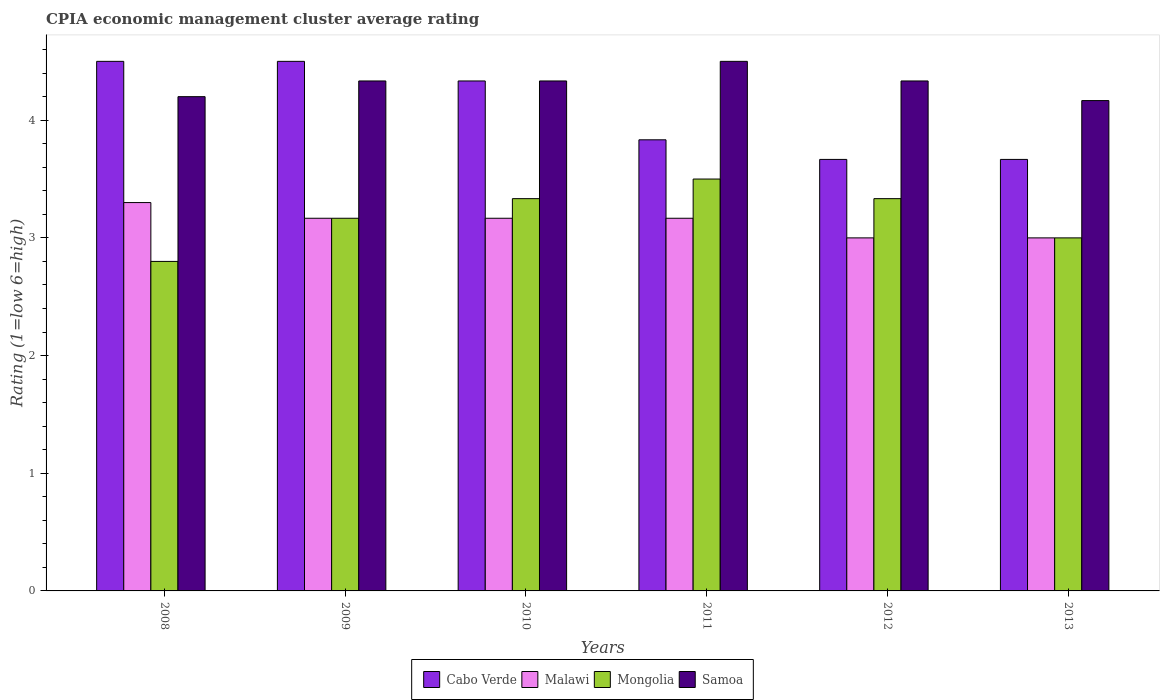How many different coloured bars are there?
Offer a terse response. 4. How many groups of bars are there?
Give a very brief answer. 6. What is the CPIA rating in Samoa in 2012?
Provide a short and direct response. 4.33. In which year was the CPIA rating in Malawi minimum?
Give a very brief answer. 2012. What is the total CPIA rating in Mongolia in the graph?
Your answer should be compact. 19.13. What is the difference between the CPIA rating in Malawi in 2011 and that in 2012?
Give a very brief answer. 0.17. What is the difference between the CPIA rating in Mongolia in 2010 and the CPIA rating in Malawi in 2009?
Give a very brief answer. 0.17. What is the average CPIA rating in Malawi per year?
Your answer should be compact. 3.13. In the year 2009, what is the difference between the CPIA rating in Mongolia and CPIA rating in Cabo Verde?
Offer a terse response. -1.33. What is the ratio of the CPIA rating in Mongolia in 2009 to that in 2012?
Your response must be concise. 0.95. Is the difference between the CPIA rating in Mongolia in 2008 and 2009 greater than the difference between the CPIA rating in Cabo Verde in 2008 and 2009?
Provide a short and direct response. No. What is the difference between the highest and the lowest CPIA rating in Samoa?
Give a very brief answer. 0.33. In how many years, is the CPIA rating in Malawi greater than the average CPIA rating in Malawi taken over all years?
Offer a terse response. 4. Is it the case that in every year, the sum of the CPIA rating in Samoa and CPIA rating in Cabo Verde is greater than the sum of CPIA rating in Malawi and CPIA rating in Mongolia?
Your answer should be compact. No. What does the 2nd bar from the left in 2012 represents?
Ensure brevity in your answer.  Malawi. What does the 2nd bar from the right in 2012 represents?
Provide a short and direct response. Mongolia. How many bars are there?
Provide a short and direct response. 24. Does the graph contain any zero values?
Provide a succinct answer. No. Does the graph contain grids?
Offer a terse response. No. How are the legend labels stacked?
Give a very brief answer. Horizontal. What is the title of the graph?
Provide a short and direct response. CPIA economic management cluster average rating. Does "Papua New Guinea" appear as one of the legend labels in the graph?
Ensure brevity in your answer.  No. What is the label or title of the Y-axis?
Make the answer very short. Rating (1=low 6=high). What is the Rating (1=low 6=high) of Cabo Verde in 2008?
Offer a very short reply. 4.5. What is the Rating (1=low 6=high) of Malawi in 2008?
Ensure brevity in your answer.  3.3. What is the Rating (1=low 6=high) of Cabo Verde in 2009?
Your response must be concise. 4.5. What is the Rating (1=low 6=high) in Malawi in 2009?
Offer a terse response. 3.17. What is the Rating (1=low 6=high) in Mongolia in 2009?
Make the answer very short. 3.17. What is the Rating (1=low 6=high) of Samoa in 2009?
Ensure brevity in your answer.  4.33. What is the Rating (1=low 6=high) of Cabo Verde in 2010?
Your answer should be compact. 4.33. What is the Rating (1=low 6=high) of Malawi in 2010?
Your answer should be compact. 3.17. What is the Rating (1=low 6=high) in Mongolia in 2010?
Provide a succinct answer. 3.33. What is the Rating (1=low 6=high) in Samoa in 2010?
Your answer should be very brief. 4.33. What is the Rating (1=low 6=high) in Cabo Verde in 2011?
Provide a short and direct response. 3.83. What is the Rating (1=low 6=high) of Malawi in 2011?
Provide a succinct answer. 3.17. What is the Rating (1=low 6=high) of Samoa in 2011?
Your answer should be compact. 4.5. What is the Rating (1=low 6=high) in Cabo Verde in 2012?
Keep it short and to the point. 3.67. What is the Rating (1=low 6=high) in Mongolia in 2012?
Offer a very short reply. 3.33. What is the Rating (1=low 6=high) of Samoa in 2012?
Your answer should be compact. 4.33. What is the Rating (1=low 6=high) of Cabo Verde in 2013?
Your response must be concise. 3.67. What is the Rating (1=low 6=high) of Malawi in 2013?
Offer a very short reply. 3. What is the Rating (1=low 6=high) in Samoa in 2013?
Your answer should be compact. 4.17. Across all years, what is the maximum Rating (1=low 6=high) in Cabo Verde?
Provide a short and direct response. 4.5. Across all years, what is the maximum Rating (1=low 6=high) of Malawi?
Your response must be concise. 3.3. Across all years, what is the minimum Rating (1=low 6=high) of Cabo Verde?
Offer a very short reply. 3.67. Across all years, what is the minimum Rating (1=low 6=high) in Malawi?
Your answer should be very brief. 3. Across all years, what is the minimum Rating (1=low 6=high) of Mongolia?
Your response must be concise. 2.8. Across all years, what is the minimum Rating (1=low 6=high) of Samoa?
Make the answer very short. 4.17. What is the total Rating (1=low 6=high) in Cabo Verde in the graph?
Your answer should be very brief. 24.5. What is the total Rating (1=low 6=high) in Mongolia in the graph?
Your response must be concise. 19.13. What is the total Rating (1=low 6=high) in Samoa in the graph?
Make the answer very short. 25.87. What is the difference between the Rating (1=low 6=high) in Cabo Verde in 2008 and that in 2009?
Offer a terse response. 0. What is the difference between the Rating (1=low 6=high) of Malawi in 2008 and that in 2009?
Provide a succinct answer. 0.13. What is the difference between the Rating (1=low 6=high) of Mongolia in 2008 and that in 2009?
Your response must be concise. -0.37. What is the difference between the Rating (1=low 6=high) of Samoa in 2008 and that in 2009?
Keep it short and to the point. -0.13. What is the difference between the Rating (1=low 6=high) in Cabo Verde in 2008 and that in 2010?
Your response must be concise. 0.17. What is the difference between the Rating (1=low 6=high) of Malawi in 2008 and that in 2010?
Provide a succinct answer. 0.13. What is the difference between the Rating (1=low 6=high) in Mongolia in 2008 and that in 2010?
Keep it short and to the point. -0.53. What is the difference between the Rating (1=low 6=high) of Samoa in 2008 and that in 2010?
Provide a succinct answer. -0.13. What is the difference between the Rating (1=low 6=high) of Cabo Verde in 2008 and that in 2011?
Make the answer very short. 0.67. What is the difference between the Rating (1=low 6=high) of Malawi in 2008 and that in 2011?
Your answer should be very brief. 0.13. What is the difference between the Rating (1=low 6=high) in Mongolia in 2008 and that in 2011?
Offer a very short reply. -0.7. What is the difference between the Rating (1=low 6=high) of Malawi in 2008 and that in 2012?
Your response must be concise. 0.3. What is the difference between the Rating (1=low 6=high) of Mongolia in 2008 and that in 2012?
Make the answer very short. -0.53. What is the difference between the Rating (1=low 6=high) of Samoa in 2008 and that in 2012?
Ensure brevity in your answer.  -0.13. What is the difference between the Rating (1=low 6=high) of Cabo Verde in 2008 and that in 2013?
Provide a succinct answer. 0.83. What is the difference between the Rating (1=low 6=high) in Malawi in 2008 and that in 2013?
Offer a terse response. 0.3. What is the difference between the Rating (1=low 6=high) in Mongolia in 2008 and that in 2013?
Provide a short and direct response. -0.2. What is the difference between the Rating (1=low 6=high) of Malawi in 2009 and that in 2010?
Make the answer very short. 0. What is the difference between the Rating (1=low 6=high) of Mongolia in 2009 and that in 2010?
Your response must be concise. -0.17. What is the difference between the Rating (1=low 6=high) in Mongolia in 2009 and that in 2011?
Your answer should be compact. -0.33. What is the difference between the Rating (1=low 6=high) in Samoa in 2009 and that in 2012?
Your answer should be very brief. 0. What is the difference between the Rating (1=low 6=high) in Cabo Verde in 2009 and that in 2013?
Ensure brevity in your answer.  0.83. What is the difference between the Rating (1=low 6=high) of Malawi in 2009 and that in 2013?
Provide a succinct answer. 0.17. What is the difference between the Rating (1=low 6=high) in Samoa in 2009 and that in 2013?
Keep it short and to the point. 0.17. What is the difference between the Rating (1=low 6=high) in Samoa in 2010 and that in 2011?
Your answer should be very brief. -0.17. What is the difference between the Rating (1=low 6=high) in Cabo Verde in 2010 and that in 2012?
Make the answer very short. 0.67. What is the difference between the Rating (1=low 6=high) in Cabo Verde in 2011 and that in 2012?
Offer a very short reply. 0.17. What is the difference between the Rating (1=low 6=high) of Malawi in 2011 and that in 2012?
Give a very brief answer. 0.17. What is the difference between the Rating (1=low 6=high) in Mongolia in 2011 and that in 2012?
Your answer should be very brief. 0.17. What is the difference between the Rating (1=low 6=high) of Malawi in 2011 and that in 2013?
Your response must be concise. 0.17. What is the difference between the Rating (1=low 6=high) in Samoa in 2011 and that in 2013?
Provide a short and direct response. 0.33. What is the difference between the Rating (1=low 6=high) of Malawi in 2012 and that in 2013?
Give a very brief answer. 0. What is the difference between the Rating (1=low 6=high) of Mongolia in 2012 and that in 2013?
Your answer should be very brief. 0.33. What is the difference between the Rating (1=low 6=high) in Samoa in 2012 and that in 2013?
Your response must be concise. 0.17. What is the difference between the Rating (1=low 6=high) of Cabo Verde in 2008 and the Rating (1=low 6=high) of Samoa in 2009?
Offer a very short reply. 0.17. What is the difference between the Rating (1=low 6=high) in Malawi in 2008 and the Rating (1=low 6=high) in Mongolia in 2009?
Offer a terse response. 0.13. What is the difference between the Rating (1=low 6=high) in Malawi in 2008 and the Rating (1=low 6=high) in Samoa in 2009?
Give a very brief answer. -1.03. What is the difference between the Rating (1=low 6=high) of Mongolia in 2008 and the Rating (1=low 6=high) of Samoa in 2009?
Make the answer very short. -1.53. What is the difference between the Rating (1=low 6=high) of Cabo Verde in 2008 and the Rating (1=low 6=high) of Mongolia in 2010?
Ensure brevity in your answer.  1.17. What is the difference between the Rating (1=low 6=high) in Cabo Verde in 2008 and the Rating (1=low 6=high) in Samoa in 2010?
Make the answer very short. 0.17. What is the difference between the Rating (1=low 6=high) of Malawi in 2008 and the Rating (1=low 6=high) of Mongolia in 2010?
Provide a short and direct response. -0.03. What is the difference between the Rating (1=low 6=high) of Malawi in 2008 and the Rating (1=low 6=high) of Samoa in 2010?
Ensure brevity in your answer.  -1.03. What is the difference between the Rating (1=low 6=high) of Mongolia in 2008 and the Rating (1=low 6=high) of Samoa in 2010?
Offer a terse response. -1.53. What is the difference between the Rating (1=low 6=high) in Cabo Verde in 2008 and the Rating (1=low 6=high) in Malawi in 2011?
Keep it short and to the point. 1.33. What is the difference between the Rating (1=low 6=high) of Malawi in 2008 and the Rating (1=low 6=high) of Mongolia in 2011?
Your answer should be very brief. -0.2. What is the difference between the Rating (1=low 6=high) of Cabo Verde in 2008 and the Rating (1=low 6=high) of Mongolia in 2012?
Give a very brief answer. 1.17. What is the difference between the Rating (1=low 6=high) in Cabo Verde in 2008 and the Rating (1=low 6=high) in Samoa in 2012?
Provide a short and direct response. 0.17. What is the difference between the Rating (1=low 6=high) of Malawi in 2008 and the Rating (1=low 6=high) of Mongolia in 2012?
Keep it short and to the point. -0.03. What is the difference between the Rating (1=low 6=high) in Malawi in 2008 and the Rating (1=low 6=high) in Samoa in 2012?
Your response must be concise. -1.03. What is the difference between the Rating (1=low 6=high) of Mongolia in 2008 and the Rating (1=low 6=high) of Samoa in 2012?
Provide a succinct answer. -1.53. What is the difference between the Rating (1=low 6=high) in Cabo Verde in 2008 and the Rating (1=low 6=high) in Malawi in 2013?
Your answer should be very brief. 1.5. What is the difference between the Rating (1=low 6=high) of Cabo Verde in 2008 and the Rating (1=low 6=high) of Mongolia in 2013?
Provide a short and direct response. 1.5. What is the difference between the Rating (1=low 6=high) in Malawi in 2008 and the Rating (1=low 6=high) in Samoa in 2013?
Make the answer very short. -0.87. What is the difference between the Rating (1=low 6=high) in Mongolia in 2008 and the Rating (1=low 6=high) in Samoa in 2013?
Give a very brief answer. -1.37. What is the difference between the Rating (1=low 6=high) of Cabo Verde in 2009 and the Rating (1=low 6=high) of Malawi in 2010?
Your answer should be compact. 1.33. What is the difference between the Rating (1=low 6=high) of Cabo Verde in 2009 and the Rating (1=low 6=high) of Samoa in 2010?
Make the answer very short. 0.17. What is the difference between the Rating (1=low 6=high) of Malawi in 2009 and the Rating (1=low 6=high) of Mongolia in 2010?
Keep it short and to the point. -0.17. What is the difference between the Rating (1=low 6=high) of Malawi in 2009 and the Rating (1=low 6=high) of Samoa in 2010?
Your response must be concise. -1.17. What is the difference between the Rating (1=low 6=high) of Mongolia in 2009 and the Rating (1=low 6=high) of Samoa in 2010?
Your answer should be compact. -1.17. What is the difference between the Rating (1=low 6=high) in Cabo Verde in 2009 and the Rating (1=low 6=high) in Mongolia in 2011?
Your response must be concise. 1. What is the difference between the Rating (1=low 6=high) in Malawi in 2009 and the Rating (1=low 6=high) in Mongolia in 2011?
Give a very brief answer. -0.33. What is the difference between the Rating (1=low 6=high) of Malawi in 2009 and the Rating (1=low 6=high) of Samoa in 2011?
Your answer should be very brief. -1.33. What is the difference between the Rating (1=low 6=high) in Mongolia in 2009 and the Rating (1=low 6=high) in Samoa in 2011?
Ensure brevity in your answer.  -1.33. What is the difference between the Rating (1=low 6=high) of Cabo Verde in 2009 and the Rating (1=low 6=high) of Malawi in 2012?
Your answer should be compact. 1.5. What is the difference between the Rating (1=low 6=high) of Cabo Verde in 2009 and the Rating (1=low 6=high) of Mongolia in 2012?
Keep it short and to the point. 1.17. What is the difference between the Rating (1=low 6=high) of Malawi in 2009 and the Rating (1=low 6=high) of Mongolia in 2012?
Your answer should be very brief. -0.17. What is the difference between the Rating (1=low 6=high) in Malawi in 2009 and the Rating (1=low 6=high) in Samoa in 2012?
Keep it short and to the point. -1.17. What is the difference between the Rating (1=low 6=high) of Mongolia in 2009 and the Rating (1=low 6=high) of Samoa in 2012?
Provide a short and direct response. -1.17. What is the difference between the Rating (1=low 6=high) in Malawi in 2010 and the Rating (1=low 6=high) in Mongolia in 2011?
Your response must be concise. -0.33. What is the difference between the Rating (1=low 6=high) of Malawi in 2010 and the Rating (1=low 6=high) of Samoa in 2011?
Offer a terse response. -1.33. What is the difference between the Rating (1=low 6=high) in Mongolia in 2010 and the Rating (1=low 6=high) in Samoa in 2011?
Your response must be concise. -1.17. What is the difference between the Rating (1=low 6=high) in Cabo Verde in 2010 and the Rating (1=low 6=high) in Malawi in 2012?
Offer a terse response. 1.33. What is the difference between the Rating (1=low 6=high) in Cabo Verde in 2010 and the Rating (1=low 6=high) in Samoa in 2012?
Offer a terse response. 0. What is the difference between the Rating (1=low 6=high) of Malawi in 2010 and the Rating (1=low 6=high) of Mongolia in 2012?
Give a very brief answer. -0.17. What is the difference between the Rating (1=low 6=high) of Malawi in 2010 and the Rating (1=low 6=high) of Samoa in 2012?
Your answer should be very brief. -1.17. What is the difference between the Rating (1=low 6=high) in Mongolia in 2010 and the Rating (1=low 6=high) in Samoa in 2012?
Offer a very short reply. -1. What is the difference between the Rating (1=low 6=high) of Cabo Verde in 2010 and the Rating (1=low 6=high) of Malawi in 2013?
Your response must be concise. 1.33. What is the difference between the Rating (1=low 6=high) of Cabo Verde in 2010 and the Rating (1=low 6=high) of Mongolia in 2013?
Your answer should be very brief. 1.33. What is the difference between the Rating (1=low 6=high) of Malawi in 2010 and the Rating (1=low 6=high) of Mongolia in 2013?
Keep it short and to the point. 0.17. What is the difference between the Rating (1=low 6=high) in Cabo Verde in 2011 and the Rating (1=low 6=high) in Mongolia in 2012?
Your response must be concise. 0.5. What is the difference between the Rating (1=low 6=high) of Malawi in 2011 and the Rating (1=low 6=high) of Mongolia in 2012?
Your answer should be very brief. -0.17. What is the difference between the Rating (1=low 6=high) in Malawi in 2011 and the Rating (1=low 6=high) in Samoa in 2012?
Your answer should be compact. -1.17. What is the difference between the Rating (1=low 6=high) of Mongolia in 2011 and the Rating (1=low 6=high) of Samoa in 2012?
Offer a terse response. -0.83. What is the difference between the Rating (1=low 6=high) of Cabo Verde in 2011 and the Rating (1=low 6=high) of Malawi in 2013?
Your answer should be very brief. 0.83. What is the difference between the Rating (1=low 6=high) in Cabo Verde in 2011 and the Rating (1=low 6=high) in Mongolia in 2013?
Your response must be concise. 0.83. What is the difference between the Rating (1=low 6=high) in Cabo Verde in 2011 and the Rating (1=low 6=high) in Samoa in 2013?
Provide a succinct answer. -0.33. What is the difference between the Rating (1=low 6=high) of Malawi in 2011 and the Rating (1=low 6=high) of Mongolia in 2013?
Ensure brevity in your answer.  0.17. What is the difference between the Rating (1=low 6=high) of Mongolia in 2011 and the Rating (1=low 6=high) of Samoa in 2013?
Ensure brevity in your answer.  -0.67. What is the difference between the Rating (1=low 6=high) in Cabo Verde in 2012 and the Rating (1=low 6=high) in Mongolia in 2013?
Make the answer very short. 0.67. What is the difference between the Rating (1=low 6=high) in Cabo Verde in 2012 and the Rating (1=low 6=high) in Samoa in 2013?
Offer a very short reply. -0.5. What is the difference between the Rating (1=low 6=high) in Malawi in 2012 and the Rating (1=low 6=high) in Samoa in 2013?
Ensure brevity in your answer.  -1.17. What is the difference between the Rating (1=low 6=high) of Mongolia in 2012 and the Rating (1=low 6=high) of Samoa in 2013?
Provide a succinct answer. -0.83. What is the average Rating (1=low 6=high) in Cabo Verde per year?
Your response must be concise. 4.08. What is the average Rating (1=low 6=high) of Malawi per year?
Offer a very short reply. 3.13. What is the average Rating (1=low 6=high) of Mongolia per year?
Ensure brevity in your answer.  3.19. What is the average Rating (1=low 6=high) of Samoa per year?
Offer a very short reply. 4.31. In the year 2008, what is the difference between the Rating (1=low 6=high) in Cabo Verde and Rating (1=low 6=high) in Malawi?
Provide a short and direct response. 1.2. In the year 2008, what is the difference between the Rating (1=low 6=high) of Cabo Verde and Rating (1=low 6=high) of Samoa?
Give a very brief answer. 0.3. In the year 2008, what is the difference between the Rating (1=low 6=high) of Malawi and Rating (1=low 6=high) of Mongolia?
Provide a short and direct response. 0.5. In the year 2008, what is the difference between the Rating (1=low 6=high) in Malawi and Rating (1=low 6=high) in Samoa?
Make the answer very short. -0.9. In the year 2008, what is the difference between the Rating (1=low 6=high) in Mongolia and Rating (1=low 6=high) in Samoa?
Your response must be concise. -1.4. In the year 2009, what is the difference between the Rating (1=low 6=high) of Cabo Verde and Rating (1=low 6=high) of Malawi?
Your answer should be very brief. 1.33. In the year 2009, what is the difference between the Rating (1=low 6=high) of Cabo Verde and Rating (1=low 6=high) of Mongolia?
Make the answer very short. 1.33. In the year 2009, what is the difference between the Rating (1=low 6=high) of Cabo Verde and Rating (1=low 6=high) of Samoa?
Provide a short and direct response. 0.17. In the year 2009, what is the difference between the Rating (1=low 6=high) in Malawi and Rating (1=low 6=high) in Mongolia?
Your answer should be compact. 0. In the year 2009, what is the difference between the Rating (1=low 6=high) in Malawi and Rating (1=low 6=high) in Samoa?
Provide a short and direct response. -1.17. In the year 2009, what is the difference between the Rating (1=low 6=high) of Mongolia and Rating (1=low 6=high) of Samoa?
Give a very brief answer. -1.17. In the year 2010, what is the difference between the Rating (1=low 6=high) in Cabo Verde and Rating (1=low 6=high) in Malawi?
Offer a terse response. 1.17. In the year 2010, what is the difference between the Rating (1=low 6=high) in Cabo Verde and Rating (1=low 6=high) in Mongolia?
Keep it short and to the point. 1. In the year 2010, what is the difference between the Rating (1=low 6=high) in Cabo Verde and Rating (1=low 6=high) in Samoa?
Ensure brevity in your answer.  0. In the year 2010, what is the difference between the Rating (1=low 6=high) of Malawi and Rating (1=low 6=high) of Samoa?
Make the answer very short. -1.17. In the year 2011, what is the difference between the Rating (1=low 6=high) of Cabo Verde and Rating (1=low 6=high) of Malawi?
Give a very brief answer. 0.67. In the year 2011, what is the difference between the Rating (1=low 6=high) in Cabo Verde and Rating (1=low 6=high) in Mongolia?
Provide a succinct answer. 0.33. In the year 2011, what is the difference between the Rating (1=low 6=high) of Malawi and Rating (1=low 6=high) of Samoa?
Give a very brief answer. -1.33. In the year 2011, what is the difference between the Rating (1=low 6=high) in Mongolia and Rating (1=low 6=high) in Samoa?
Provide a succinct answer. -1. In the year 2012, what is the difference between the Rating (1=low 6=high) of Cabo Verde and Rating (1=low 6=high) of Mongolia?
Your answer should be compact. 0.33. In the year 2012, what is the difference between the Rating (1=low 6=high) in Cabo Verde and Rating (1=low 6=high) in Samoa?
Offer a very short reply. -0.67. In the year 2012, what is the difference between the Rating (1=low 6=high) of Malawi and Rating (1=low 6=high) of Samoa?
Offer a very short reply. -1.33. In the year 2013, what is the difference between the Rating (1=low 6=high) of Malawi and Rating (1=low 6=high) of Mongolia?
Provide a short and direct response. 0. In the year 2013, what is the difference between the Rating (1=low 6=high) in Malawi and Rating (1=low 6=high) in Samoa?
Provide a short and direct response. -1.17. In the year 2013, what is the difference between the Rating (1=low 6=high) of Mongolia and Rating (1=low 6=high) of Samoa?
Keep it short and to the point. -1.17. What is the ratio of the Rating (1=low 6=high) in Cabo Verde in 2008 to that in 2009?
Keep it short and to the point. 1. What is the ratio of the Rating (1=low 6=high) in Malawi in 2008 to that in 2009?
Your response must be concise. 1.04. What is the ratio of the Rating (1=low 6=high) of Mongolia in 2008 to that in 2009?
Provide a short and direct response. 0.88. What is the ratio of the Rating (1=low 6=high) in Samoa in 2008 to that in 2009?
Offer a very short reply. 0.97. What is the ratio of the Rating (1=low 6=high) in Malawi in 2008 to that in 2010?
Your answer should be compact. 1.04. What is the ratio of the Rating (1=low 6=high) of Mongolia in 2008 to that in 2010?
Provide a short and direct response. 0.84. What is the ratio of the Rating (1=low 6=high) in Samoa in 2008 to that in 2010?
Your response must be concise. 0.97. What is the ratio of the Rating (1=low 6=high) of Cabo Verde in 2008 to that in 2011?
Your answer should be very brief. 1.17. What is the ratio of the Rating (1=low 6=high) of Malawi in 2008 to that in 2011?
Ensure brevity in your answer.  1.04. What is the ratio of the Rating (1=low 6=high) in Mongolia in 2008 to that in 2011?
Provide a short and direct response. 0.8. What is the ratio of the Rating (1=low 6=high) of Cabo Verde in 2008 to that in 2012?
Your answer should be compact. 1.23. What is the ratio of the Rating (1=low 6=high) of Mongolia in 2008 to that in 2012?
Offer a terse response. 0.84. What is the ratio of the Rating (1=low 6=high) in Samoa in 2008 to that in 2012?
Make the answer very short. 0.97. What is the ratio of the Rating (1=low 6=high) in Cabo Verde in 2008 to that in 2013?
Make the answer very short. 1.23. What is the ratio of the Rating (1=low 6=high) in Malawi in 2008 to that in 2013?
Your response must be concise. 1.1. What is the ratio of the Rating (1=low 6=high) in Cabo Verde in 2009 to that in 2010?
Offer a terse response. 1.04. What is the ratio of the Rating (1=low 6=high) in Samoa in 2009 to that in 2010?
Your response must be concise. 1. What is the ratio of the Rating (1=low 6=high) of Cabo Verde in 2009 to that in 2011?
Make the answer very short. 1.17. What is the ratio of the Rating (1=low 6=high) in Malawi in 2009 to that in 2011?
Ensure brevity in your answer.  1. What is the ratio of the Rating (1=low 6=high) in Mongolia in 2009 to that in 2011?
Offer a terse response. 0.9. What is the ratio of the Rating (1=low 6=high) of Cabo Verde in 2009 to that in 2012?
Provide a short and direct response. 1.23. What is the ratio of the Rating (1=low 6=high) in Malawi in 2009 to that in 2012?
Provide a short and direct response. 1.06. What is the ratio of the Rating (1=low 6=high) of Mongolia in 2009 to that in 2012?
Provide a succinct answer. 0.95. What is the ratio of the Rating (1=low 6=high) in Cabo Verde in 2009 to that in 2013?
Offer a very short reply. 1.23. What is the ratio of the Rating (1=low 6=high) of Malawi in 2009 to that in 2013?
Your answer should be very brief. 1.06. What is the ratio of the Rating (1=low 6=high) in Mongolia in 2009 to that in 2013?
Offer a terse response. 1.06. What is the ratio of the Rating (1=low 6=high) of Samoa in 2009 to that in 2013?
Your answer should be compact. 1.04. What is the ratio of the Rating (1=low 6=high) in Cabo Verde in 2010 to that in 2011?
Your answer should be compact. 1.13. What is the ratio of the Rating (1=low 6=high) of Cabo Verde in 2010 to that in 2012?
Make the answer very short. 1.18. What is the ratio of the Rating (1=low 6=high) in Malawi in 2010 to that in 2012?
Make the answer very short. 1.06. What is the ratio of the Rating (1=low 6=high) of Samoa in 2010 to that in 2012?
Offer a very short reply. 1. What is the ratio of the Rating (1=low 6=high) of Cabo Verde in 2010 to that in 2013?
Keep it short and to the point. 1.18. What is the ratio of the Rating (1=low 6=high) in Malawi in 2010 to that in 2013?
Your response must be concise. 1.06. What is the ratio of the Rating (1=low 6=high) in Cabo Verde in 2011 to that in 2012?
Keep it short and to the point. 1.05. What is the ratio of the Rating (1=low 6=high) of Malawi in 2011 to that in 2012?
Give a very brief answer. 1.06. What is the ratio of the Rating (1=low 6=high) of Cabo Verde in 2011 to that in 2013?
Give a very brief answer. 1.05. What is the ratio of the Rating (1=low 6=high) of Malawi in 2011 to that in 2013?
Provide a succinct answer. 1.06. What is the ratio of the Rating (1=low 6=high) in Cabo Verde in 2012 to that in 2013?
Your response must be concise. 1. What is the ratio of the Rating (1=low 6=high) in Samoa in 2012 to that in 2013?
Offer a very short reply. 1.04. What is the difference between the highest and the second highest Rating (1=low 6=high) of Cabo Verde?
Ensure brevity in your answer.  0. What is the difference between the highest and the second highest Rating (1=low 6=high) in Malawi?
Provide a short and direct response. 0.13. What is the difference between the highest and the second highest Rating (1=low 6=high) in Mongolia?
Give a very brief answer. 0.17. What is the difference between the highest and the second highest Rating (1=low 6=high) of Samoa?
Offer a terse response. 0.17. What is the difference between the highest and the lowest Rating (1=low 6=high) of Cabo Verde?
Give a very brief answer. 0.83. What is the difference between the highest and the lowest Rating (1=low 6=high) of Malawi?
Your response must be concise. 0.3. What is the difference between the highest and the lowest Rating (1=low 6=high) of Mongolia?
Keep it short and to the point. 0.7. 